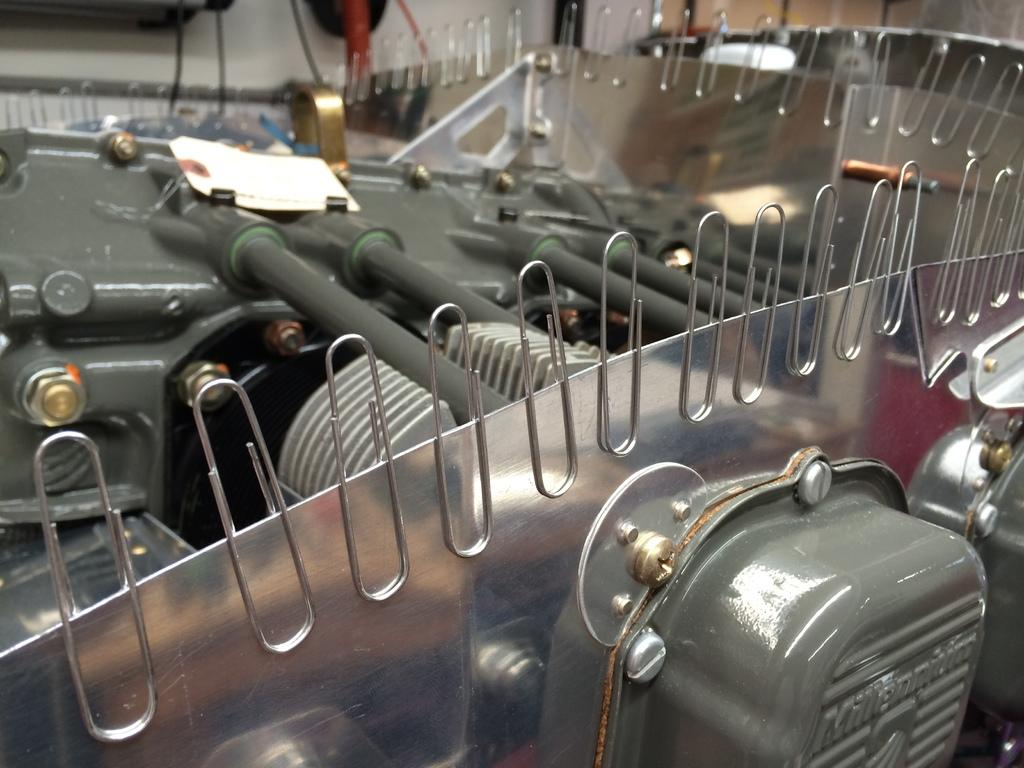What is the main subject of the image? There is an equipment in the image. Can you describe the background of the image? There is a white object in the background of the image. What can be seen attached to the equipment? There are pins visible in the image. Is there any text present in the image? Yes, there is text written in the image. Can you tell me how many rats are sitting on the equipment in the image? There are no rats present in the image; it only features an equipment with pins and text. What type of owl can be seen perched on the white object in the background? There is no owl present in the image; the background only contains a white object. 